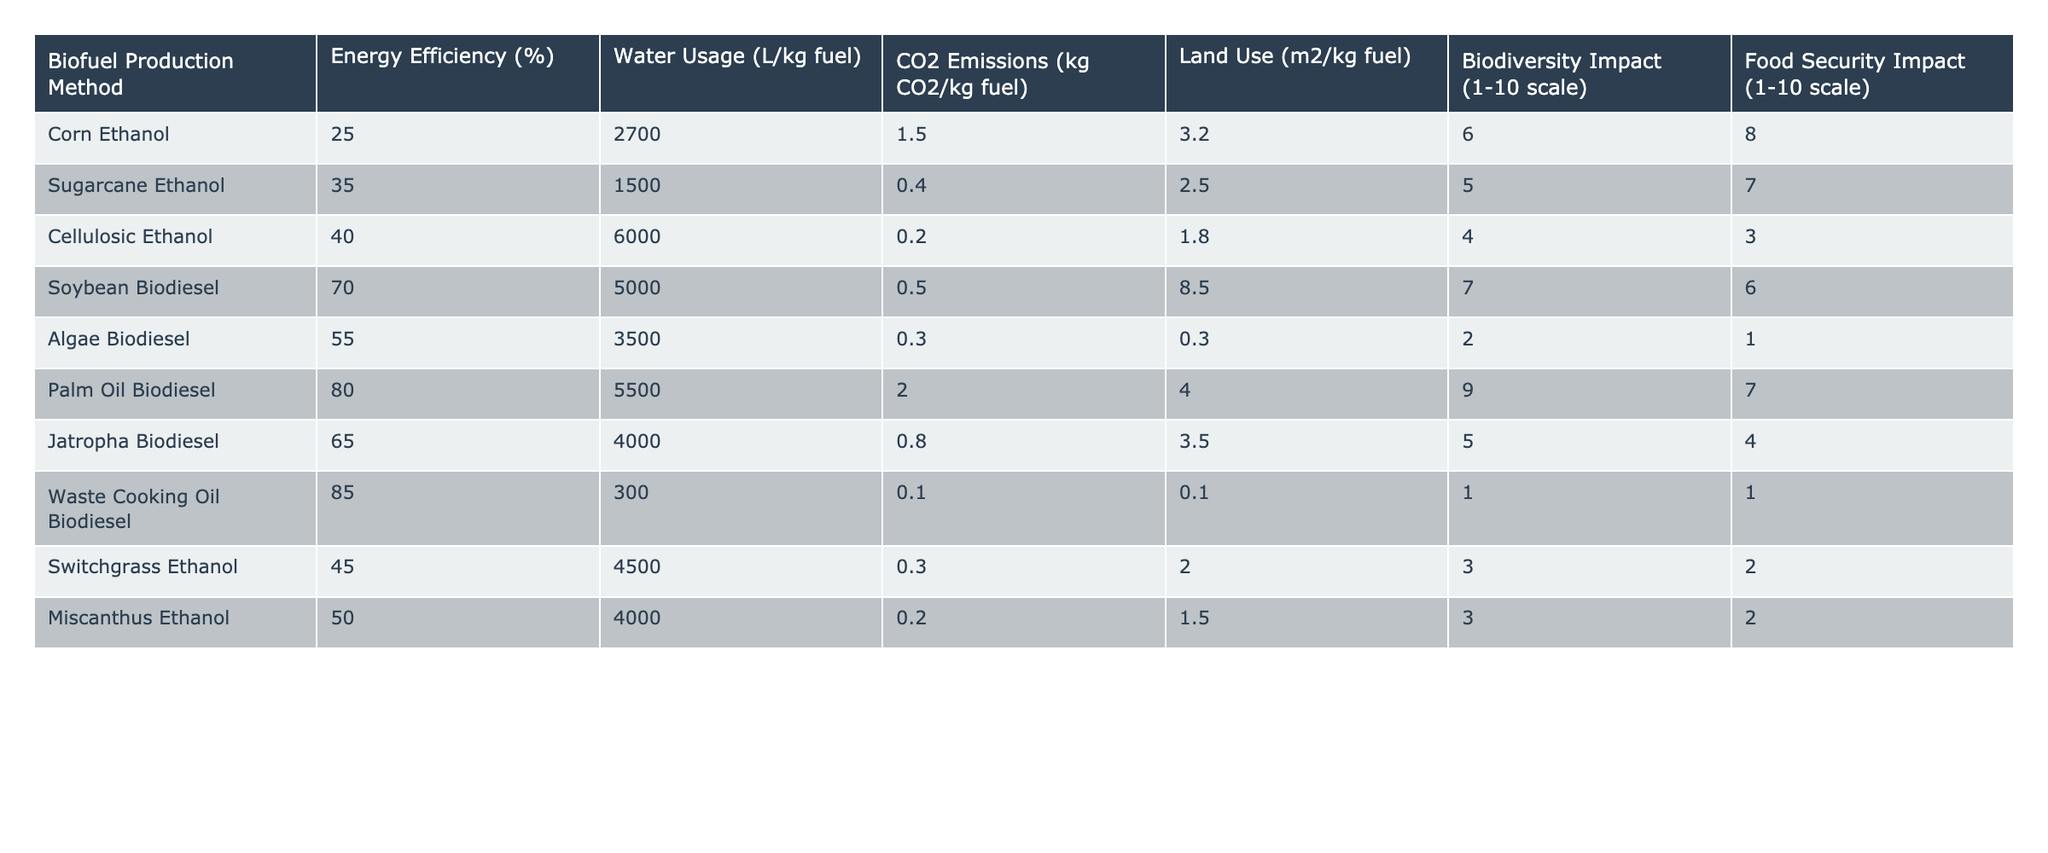What is the energy efficiency of Palm Oil Biodiesel? Referring to the table, the energy efficiency column shows that Palm Oil Biodiesel has an energy efficiency of 80%.
Answer: 80% Which biofuel production method has the lowest CO2 emissions? By examining the CO2 emissions column, Waste Cooking Oil Biodiesel has the lowest CO2 emissions at 0.1 kg CO2/kg fuel.
Answer: Waste Cooking Oil Biodiesel What is the average water usage of all the biofuel production methods listed? To find the average, sum the water usage values: 2700 + 1500 + 6000 + 5000 + 3500 + 5500 + 4000 + 300 + 4500 + 4000 = 33500. Then divide by the number of methods (10): 33500/10 = 3350.
Answer: 3350 L/kg fuel Is the biodiversity impact of Sugarcane Ethanol greater than that of Corn Ethanol? Sugarcane Ethanol has a biodiversity impact score of 5, while Corn Ethanol scores 6. Since 5 is less than 6, the answer is no.
Answer: No Which biofuel production method has the highest land use? Looking at the land use values, Soybean Biodiesel has the highest land use at 8.5 m2/kg fuel.
Answer: Soybean Biodiesel What is the difference in biodiversity impact between Jatropha Biodiesel and Algae Biodiesel? Jatropha Biodiesel has a biodiversity impact of 5 and Algae Biodiesel has a score of 2. Therefore, the difference is 5 - 2 = 3.
Answer: 3 Are the food security impacts of Soybean Biodiesel and Algae Biodiesel equal? Soybean Biodiesel has a food security impact of 6, and Algae Biodiesel has a score of 1. Since these values are not equal, the answer is no.
Answer: No Which biofuel production method has the highest energy efficiency combined with the lowest CO2 emissions? By comparing the energy efficiency and CO2 emissions, Waste Cooking Oil Biodiesel has the highest efficiency at 85% and the lowest CO2 emissions at 0.1 kg CO2/kg fuel.
Answer: Waste Cooking Oil Biodiesel Calculate the total land use of all biofuel production methods. The land use values are summed as follows: 3.2 + 2.5 + 1.8 + 8.5 + 0.3 + 4.0 + 3.5 + 0.1 + 2.0 + 1.5 = 27.4.
Answer: 27.4 m2/kg fuel Is there any biofuel production method that uses less than 1000 liters of water per kg of fuel? All methods listed have water usage values above 1000 L/kg fuel, as the lowest is 300 L/kg for Waste Cooking Oil Biodiesel. The answer is no.
Answer: No 